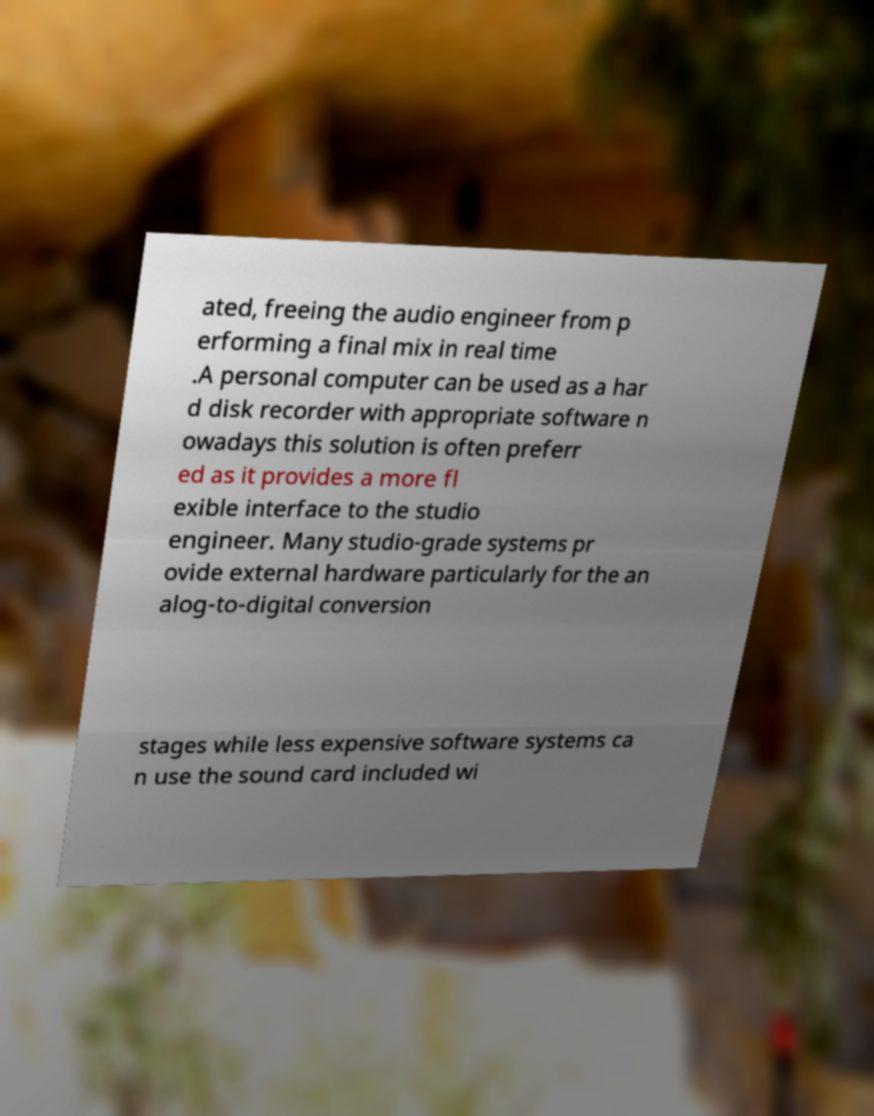There's text embedded in this image that I need extracted. Can you transcribe it verbatim? ated, freeing the audio engineer from p erforming a final mix in real time .A personal computer can be used as a har d disk recorder with appropriate software n owadays this solution is often preferr ed as it provides a more fl exible interface to the studio engineer. Many studio-grade systems pr ovide external hardware particularly for the an alog-to-digital conversion stages while less expensive software systems ca n use the sound card included wi 